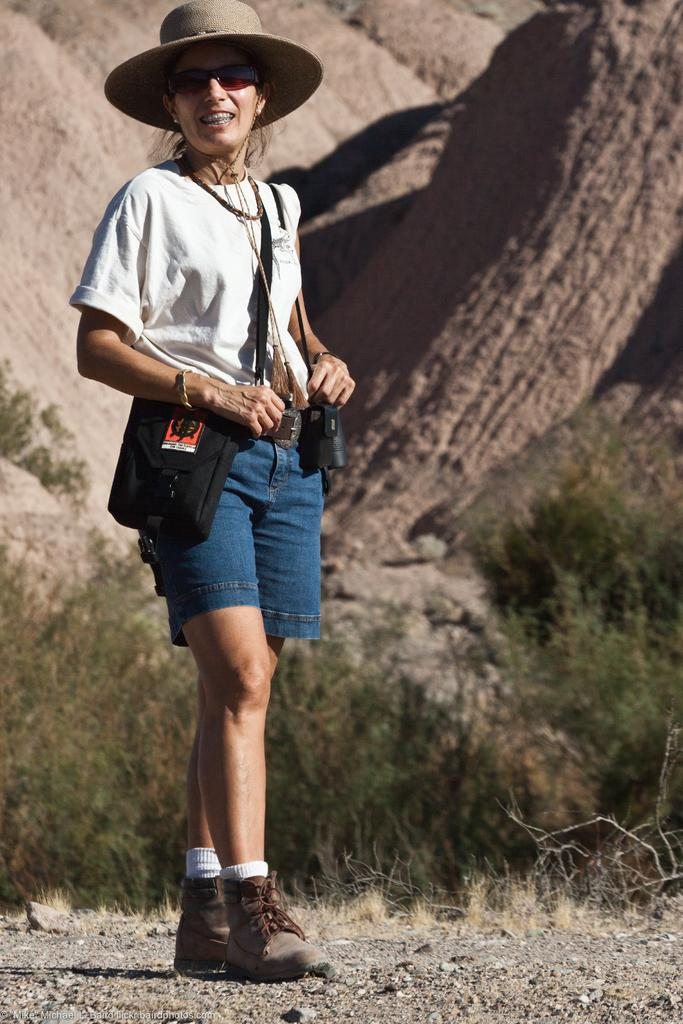Who is the main subject in the image? There is a lady in the image. What is the lady wearing on her head? The lady is wearing a hat. What is the lady carrying in her hand? The lady is carrying a bag. What type of vegetation can be seen behind the lady? There is a group of plants behind the lady. What type of natural formation is visible behind the lady? There are rocks visible behind the lady. Where are the cherries placed in the image? There are no cherries present in the image. What type of box can be seen near the lady in the image? There is no box visible near the lady in the image. 